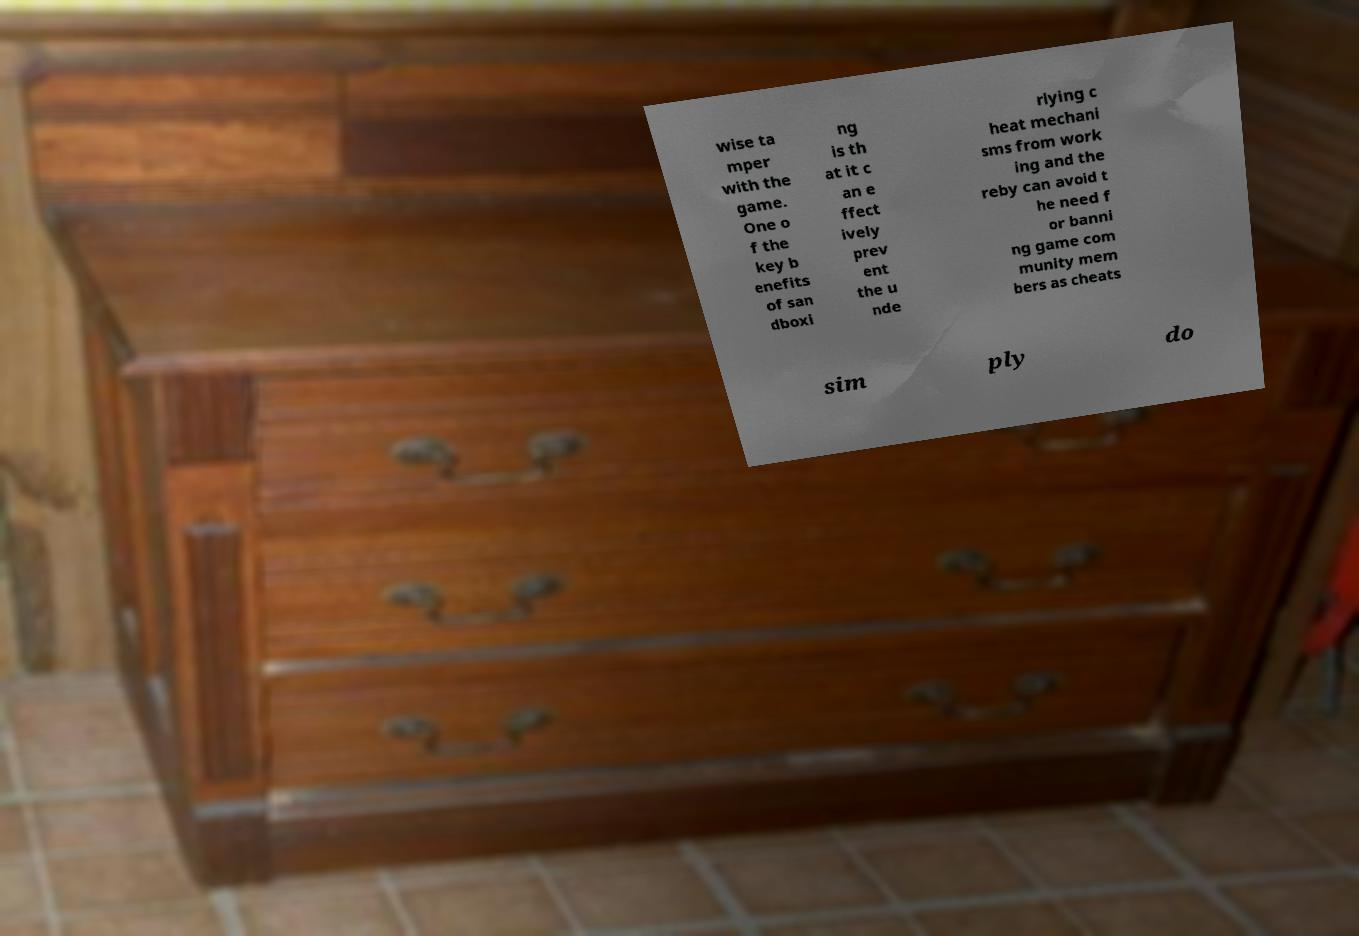There's text embedded in this image that I need extracted. Can you transcribe it verbatim? wise ta mper with the game. One o f the key b enefits of san dboxi ng is th at it c an e ffect ively prev ent the u nde rlying c heat mechani sms from work ing and the reby can avoid t he need f or banni ng game com munity mem bers as cheats sim ply do 